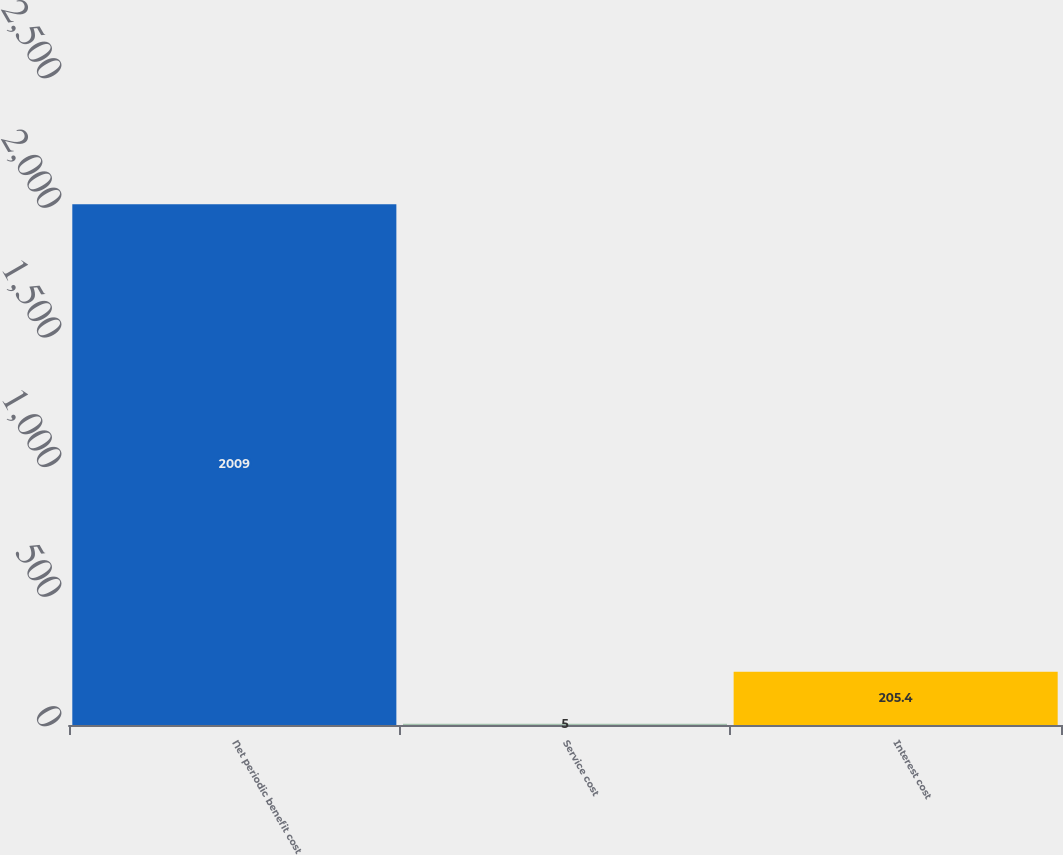Convert chart to OTSL. <chart><loc_0><loc_0><loc_500><loc_500><bar_chart><fcel>Net periodic benefit cost<fcel>Service cost<fcel>Interest cost<nl><fcel>2009<fcel>5<fcel>205.4<nl></chart> 